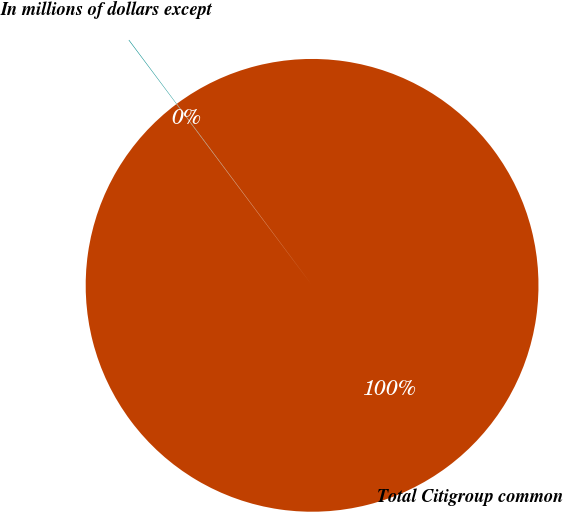<chart> <loc_0><loc_0><loc_500><loc_500><pie_chart><fcel>In millions of dollars except<fcel>Total Citigroup common<nl><fcel>0.04%<fcel>99.96%<nl></chart> 